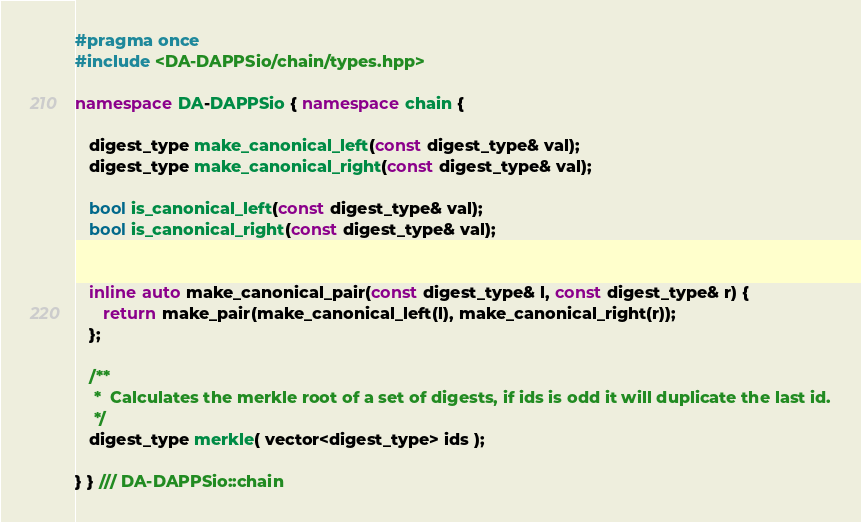<code> <loc_0><loc_0><loc_500><loc_500><_C++_>#pragma once
#include <DA-DAPPSio/chain/types.hpp>

namespace DA-DAPPSio { namespace chain {

   digest_type make_canonical_left(const digest_type& val);
   digest_type make_canonical_right(const digest_type& val);

   bool is_canonical_left(const digest_type& val);
   bool is_canonical_right(const digest_type& val);


   inline auto make_canonical_pair(const digest_type& l, const digest_type& r) {
      return make_pair(make_canonical_left(l), make_canonical_right(r));
   };

   /**
    *  Calculates the merkle root of a set of digests, if ids is odd it will duplicate the last id.
    */
   digest_type merkle( vector<digest_type> ids );

} } /// DA-DAPPSio::chain
</code> 